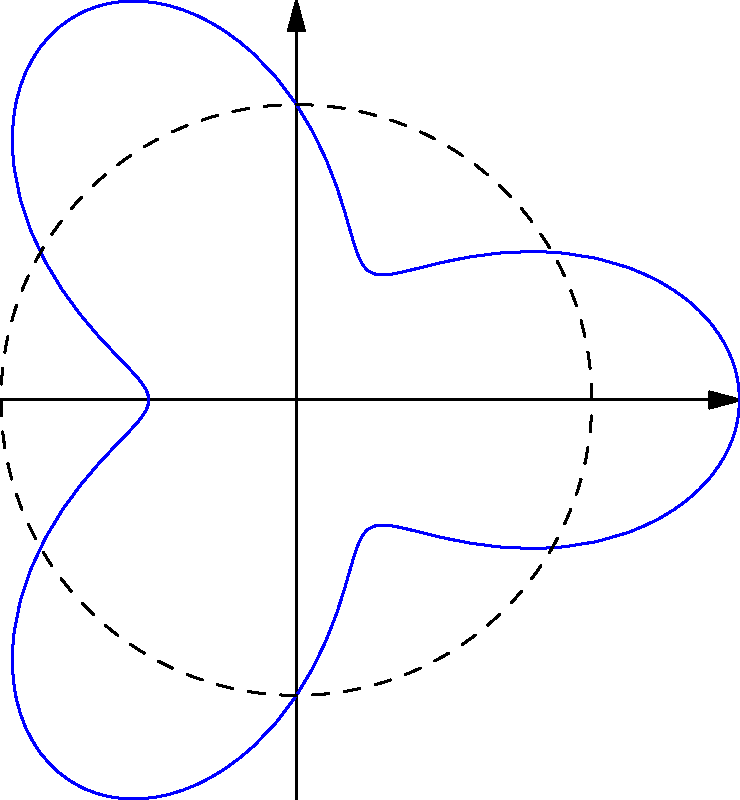A startup company has designed a logo based on the polar curve $r = 2 + \cos(3\theta)$. As part of a branding exercise, you need to calculate the area enclosed by this curve. What is the area of the logo? To find the area enclosed by a polar curve, we use the formula:

$$A = \frac{1}{2} \int_{0}^{2\pi} r^2(\theta) d\theta$$

For our curve $r = 2 + \cos(3\theta)$, we need to:

1) Square $r$:
   $r^2 = (2 + \cos(3\theta))^2 = 4 + 4\cos(3\theta) + \cos^2(3\theta)$

2) Integrate from 0 to $2\pi$:
   $$A = \frac{1}{2} \int_{0}^{2\pi} (4 + 4\cos(3\theta) + \cos^2(3\theta)) d\theta$$

3) Evaluate each term:
   - $\int_{0}^{2\pi} 4 d\theta = 4 \cdot 2\pi = 8\pi$
   - $\int_{0}^{2\pi} 4\cos(3\theta) d\theta = \frac{4}{3}[\sin(3\theta)]_{0}^{2\pi} = 0$
   - $\int_{0}^{2\pi} \cos^2(3\theta) d\theta = \int_{0}^{2\pi} \frac{1 + \cos(6\theta)}{2} d\theta = \pi$

4) Sum up the results:
   $$A = \frac{1}{2}(8\pi + 0 + \pi) = \frac{9\pi}{2}$$

Therefore, the area enclosed by the curve is $\frac{9\pi}{2}$ square units.
Answer: $\frac{9\pi}{2}$ square units 